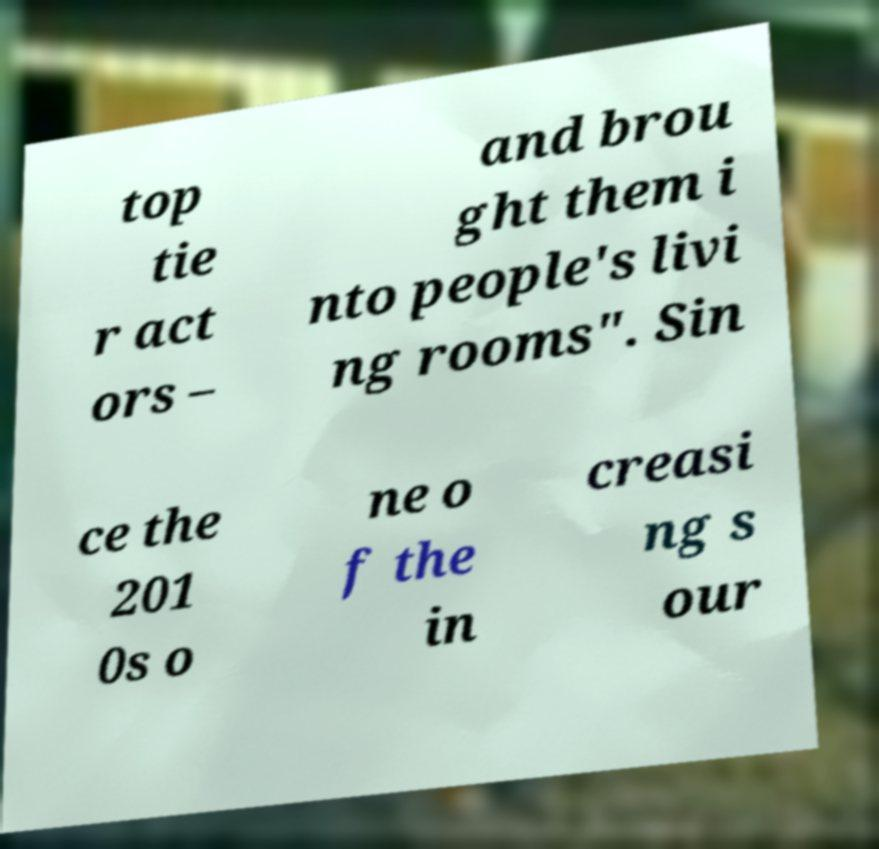Can you accurately transcribe the text from the provided image for me? top tie r act ors – and brou ght them i nto people's livi ng rooms". Sin ce the 201 0s o ne o f the in creasi ng s our 